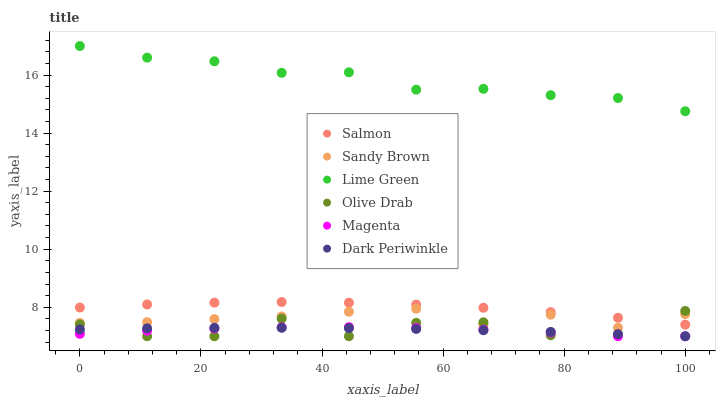Does Magenta have the minimum area under the curve?
Answer yes or no. Yes. Does Lime Green have the maximum area under the curve?
Answer yes or no. Yes. Does Salmon have the minimum area under the curve?
Answer yes or no. No. Does Salmon have the maximum area under the curve?
Answer yes or no. No. Is Dark Periwinkle the smoothest?
Answer yes or no. Yes. Is Olive Drab the roughest?
Answer yes or no. Yes. Is Salmon the smoothest?
Answer yes or no. No. Is Salmon the roughest?
Answer yes or no. No. Does Magenta have the lowest value?
Answer yes or no. Yes. Does Salmon have the lowest value?
Answer yes or no. No. Does Lime Green have the highest value?
Answer yes or no. Yes. Does Salmon have the highest value?
Answer yes or no. No. Is Dark Periwinkle less than Salmon?
Answer yes or no. Yes. Is Salmon greater than Dark Periwinkle?
Answer yes or no. Yes. Does Dark Periwinkle intersect Olive Drab?
Answer yes or no. Yes. Is Dark Periwinkle less than Olive Drab?
Answer yes or no. No. Is Dark Periwinkle greater than Olive Drab?
Answer yes or no. No. Does Dark Periwinkle intersect Salmon?
Answer yes or no. No. 